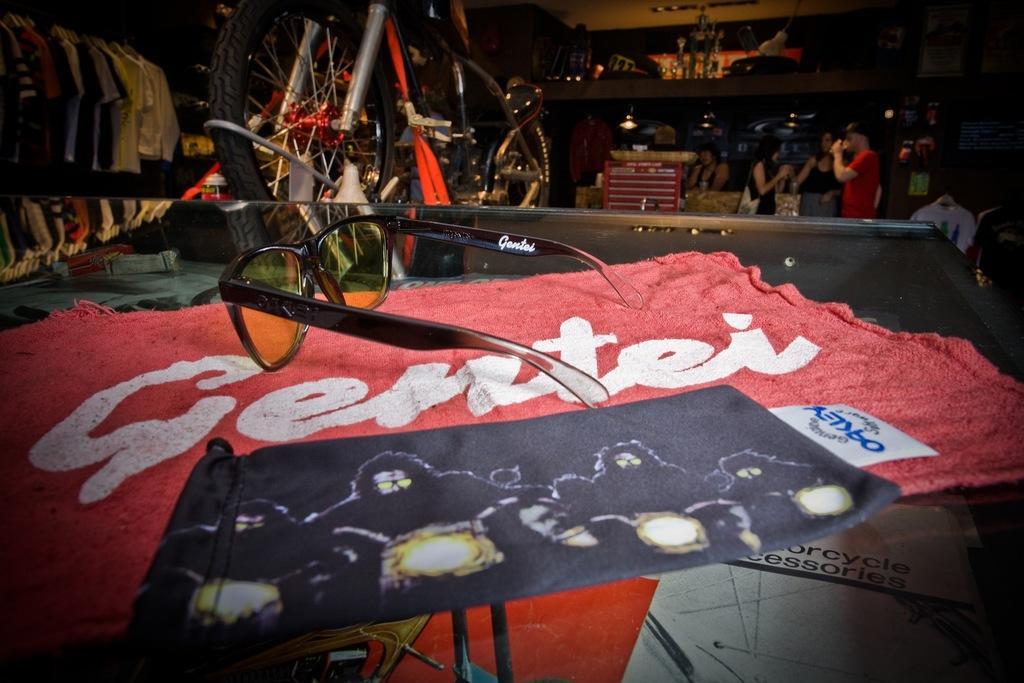Describe this image in one or two sentences. In the image we can see there are people standing and wearing clothes. Here we can see the bicycle and clothes hung to the hangers, here we can see the lights. Here we can see the glass surface on it there is a clothes and on the cloth we can see goggles. 